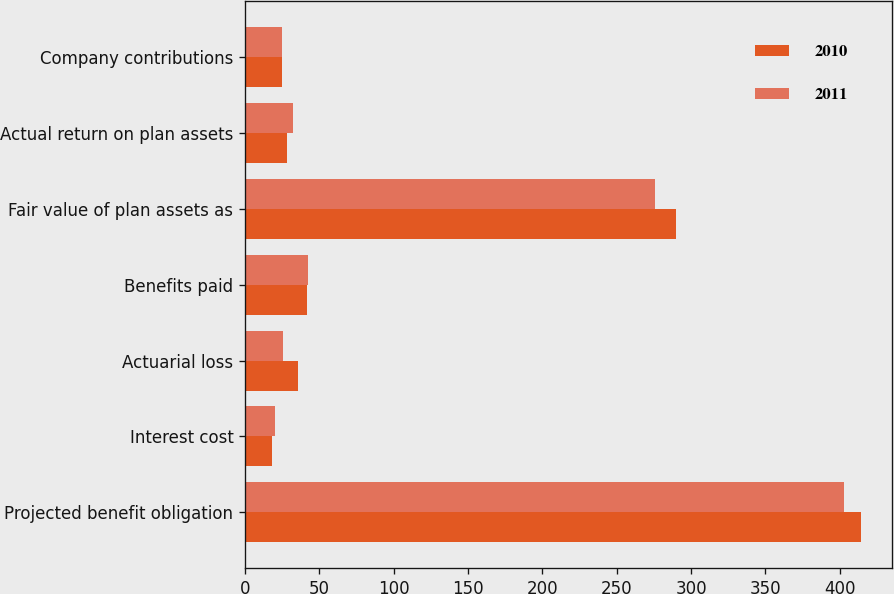<chart> <loc_0><loc_0><loc_500><loc_500><stacked_bar_chart><ecel><fcel>Projected benefit obligation<fcel>Interest cost<fcel>Actuarial loss<fcel>Benefits paid<fcel>Fair value of plan assets as<fcel>Actual return on plan assets<fcel>Company contributions<nl><fcel>2010<fcel>414.4<fcel>17.9<fcel>35.3<fcel>41.7<fcel>290.1<fcel>28.3<fcel>25<nl><fcel>2011<fcel>402.9<fcel>20.1<fcel>25.3<fcel>42.6<fcel>275.9<fcel>31.9<fcel>24.9<nl></chart> 